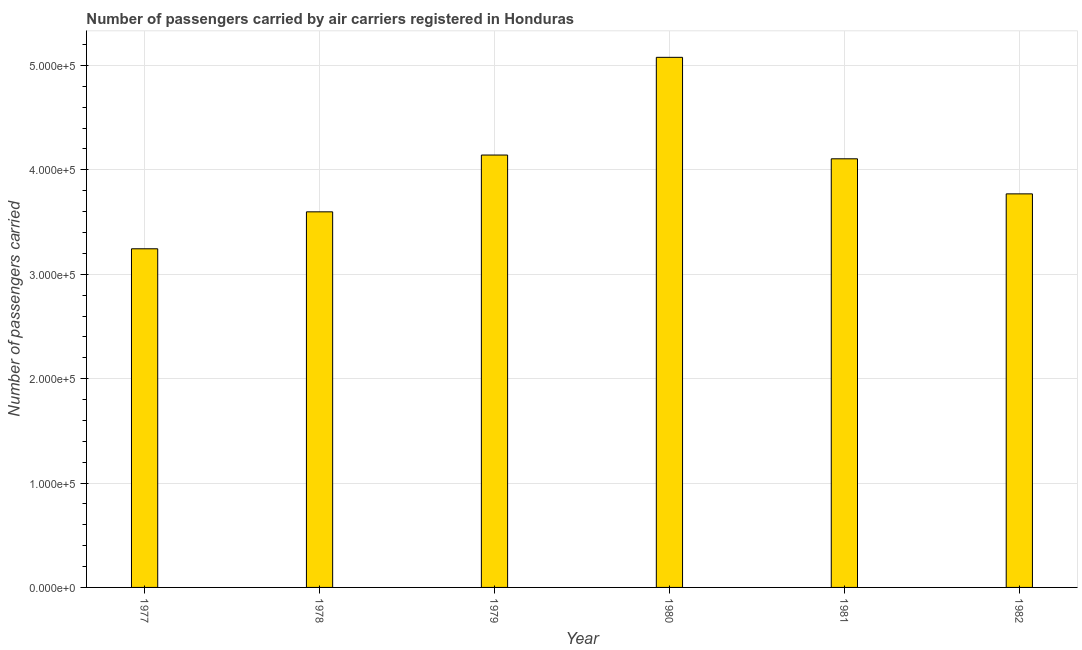Does the graph contain grids?
Provide a succinct answer. Yes. What is the title of the graph?
Give a very brief answer. Number of passengers carried by air carriers registered in Honduras. What is the label or title of the X-axis?
Provide a short and direct response. Year. What is the label or title of the Y-axis?
Your response must be concise. Number of passengers carried. What is the number of passengers carried in 1981?
Your answer should be very brief. 4.11e+05. Across all years, what is the maximum number of passengers carried?
Your response must be concise. 5.08e+05. Across all years, what is the minimum number of passengers carried?
Provide a succinct answer. 3.24e+05. In which year was the number of passengers carried maximum?
Your answer should be compact. 1980. What is the sum of the number of passengers carried?
Your answer should be compact. 2.39e+06. What is the difference between the number of passengers carried in 1979 and 1982?
Offer a very short reply. 3.72e+04. What is the average number of passengers carried per year?
Give a very brief answer. 3.99e+05. What is the median number of passengers carried?
Offer a terse response. 3.94e+05. In how many years, is the number of passengers carried greater than 200000 ?
Your answer should be compact. 6. Do a majority of the years between 1979 and 1981 (inclusive) have number of passengers carried greater than 240000 ?
Your response must be concise. Yes. What is the ratio of the number of passengers carried in 1978 to that in 1979?
Provide a short and direct response. 0.87. Is the difference between the number of passengers carried in 1981 and 1982 greater than the difference between any two years?
Ensure brevity in your answer.  No. What is the difference between the highest and the second highest number of passengers carried?
Keep it short and to the point. 9.36e+04. Is the sum of the number of passengers carried in 1978 and 1982 greater than the maximum number of passengers carried across all years?
Provide a short and direct response. Yes. What is the difference between the highest and the lowest number of passengers carried?
Provide a short and direct response. 1.83e+05. In how many years, is the number of passengers carried greater than the average number of passengers carried taken over all years?
Provide a succinct answer. 3. Are all the bars in the graph horizontal?
Make the answer very short. No. How many years are there in the graph?
Your answer should be compact. 6. What is the difference between two consecutive major ticks on the Y-axis?
Your answer should be very brief. 1.00e+05. Are the values on the major ticks of Y-axis written in scientific E-notation?
Keep it short and to the point. Yes. What is the Number of passengers carried in 1977?
Make the answer very short. 3.24e+05. What is the Number of passengers carried of 1978?
Your answer should be very brief. 3.60e+05. What is the Number of passengers carried of 1979?
Ensure brevity in your answer.  4.14e+05. What is the Number of passengers carried of 1980?
Give a very brief answer. 5.08e+05. What is the Number of passengers carried of 1981?
Your answer should be very brief. 4.11e+05. What is the Number of passengers carried in 1982?
Offer a terse response. 3.77e+05. What is the difference between the Number of passengers carried in 1977 and 1978?
Offer a very short reply. -3.54e+04. What is the difference between the Number of passengers carried in 1977 and 1979?
Offer a terse response. -8.98e+04. What is the difference between the Number of passengers carried in 1977 and 1980?
Provide a short and direct response. -1.83e+05. What is the difference between the Number of passengers carried in 1977 and 1981?
Offer a very short reply. -8.62e+04. What is the difference between the Number of passengers carried in 1977 and 1982?
Offer a very short reply. -5.26e+04. What is the difference between the Number of passengers carried in 1978 and 1979?
Your response must be concise. -5.44e+04. What is the difference between the Number of passengers carried in 1978 and 1980?
Provide a short and direct response. -1.48e+05. What is the difference between the Number of passengers carried in 1978 and 1981?
Your answer should be compact. -5.08e+04. What is the difference between the Number of passengers carried in 1978 and 1982?
Provide a succinct answer. -1.72e+04. What is the difference between the Number of passengers carried in 1979 and 1980?
Ensure brevity in your answer.  -9.36e+04. What is the difference between the Number of passengers carried in 1979 and 1981?
Offer a terse response. 3600. What is the difference between the Number of passengers carried in 1979 and 1982?
Keep it short and to the point. 3.72e+04. What is the difference between the Number of passengers carried in 1980 and 1981?
Ensure brevity in your answer.  9.72e+04. What is the difference between the Number of passengers carried in 1980 and 1982?
Provide a short and direct response. 1.31e+05. What is the difference between the Number of passengers carried in 1981 and 1982?
Your answer should be compact. 3.36e+04. What is the ratio of the Number of passengers carried in 1977 to that in 1978?
Offer a very short reply. 0.9. What is the ratio of the Number of passengers carried in 1977 to that in 1979?
Ensure brevity in your answer.  0.78. What is the ratio of the Number of passengers carried in 1977 to that in 1980?
Offer a terse response. 0.64. What is the ratio of the Number of passengers carried in 1977 to that in 1981?
Your response must be concise. 0.79. What is the ratio of the Number of passengers carried in 1977 to that in 1982?
Make the answer very short. 0.86. What is the ratio of the Number of passengers carried in 1978 to that in 1979?
Ensure brevity in your answer.  0.87. What is the ratio of the Number of passengers carried in 1978 to that in 1980?
Make the answer very short. 0.71. What is the ratio of the Number of passengers carried in 1978 to that in 1981?
Ensure brevity in your answer.  0.88. What is the ratio of the Number of passengers carried in 1978 to that in 1982?
Your answer should be very brief. 0.95. What is the ratio of the Number of passengers carried in 1979 to that in 1980?
Offer a terse response. 0.82. What is the ratio of the Number of passengers carried in 1979 to that in 1981?
Ensure brevity in your answer.  1.01. What is the ratio of the Number of passengers carried in 1979 to that in 1982?
Make the answer very short. 1.1. What is the ratio of the Number of passengers carried in 1980 to that in 1981?
Your answer should be very brief. 1.24. What is the ratio of the Number of passengers carried in 1980 to that in 1982?
Keep it short and to the point. 1.35. What is the ratio of the Number of passengers carried in 1981 to that in 1982?
Keep it short and to the point. 1.09. 